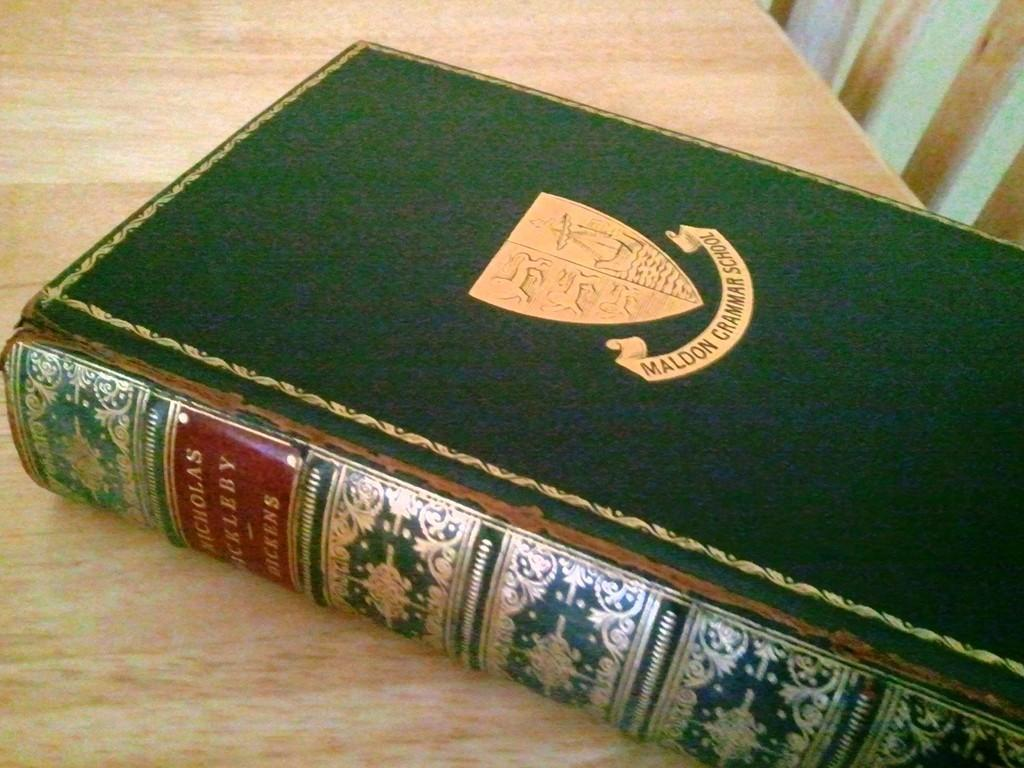<image>
Describe the image concisely. A green hard cover book with maldom grammar school and its coat of arms on the cover. 